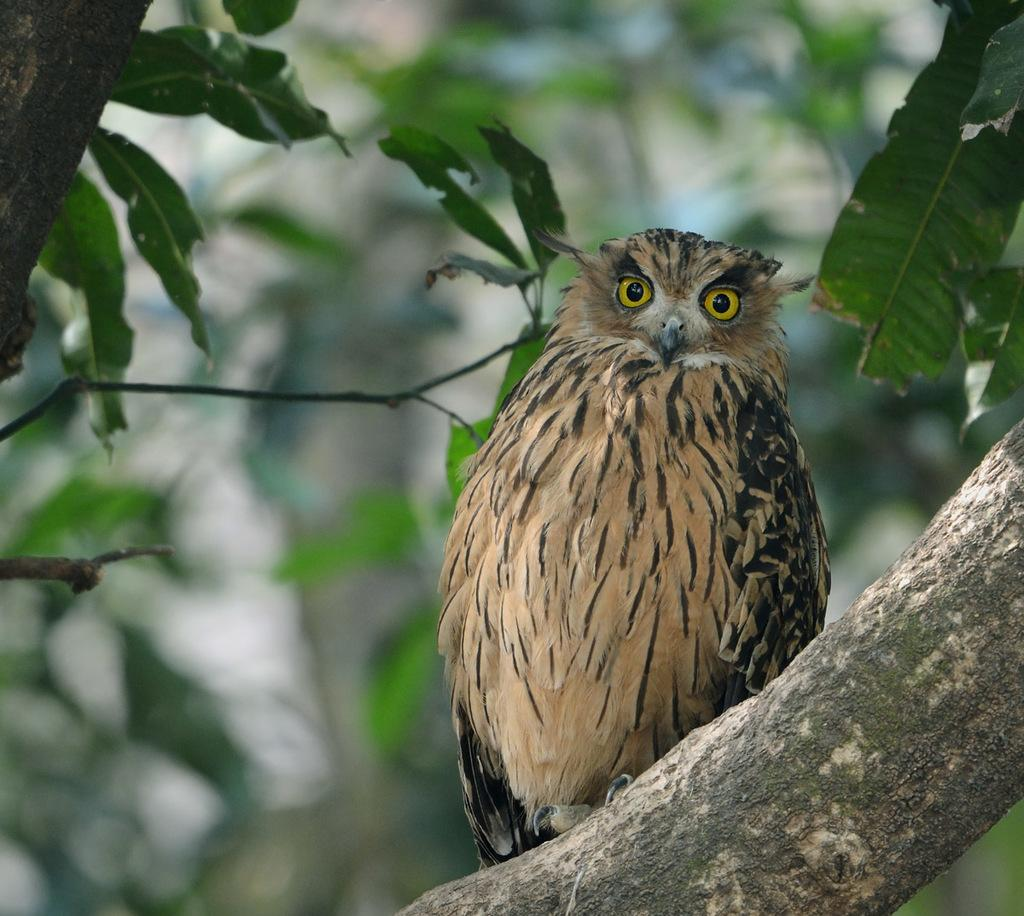What animal is present in the image? There is an owl in the image. Where is the owl located? The owl is on a tree. Can you describe the background of the image? There is a tree visible in the background of the image. What type of education does the bear receive under the umbrella in the image? There is no bear or umbrella present in the image; it features an owl on a tree. 